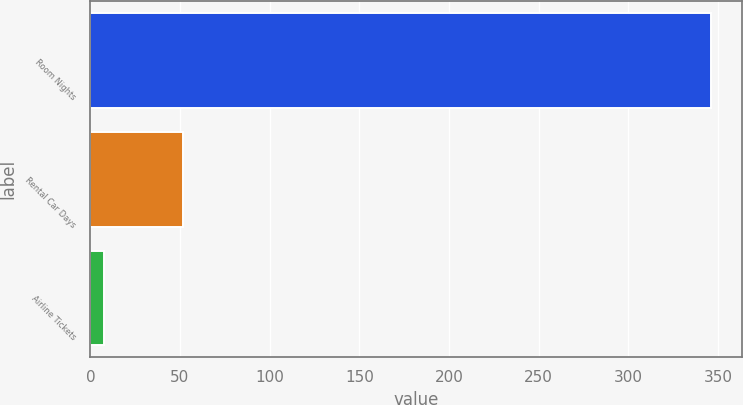Convert chart to OTSL. <chart><loc_0><loc_0><loc_500><loc_500><bar_chart><fcel>Room Nights<fcel>Rental Car Days<fcel>Airline Tickets<nl><fcel>346<fcel>51.8<fcel>7.8<nl></chart> 